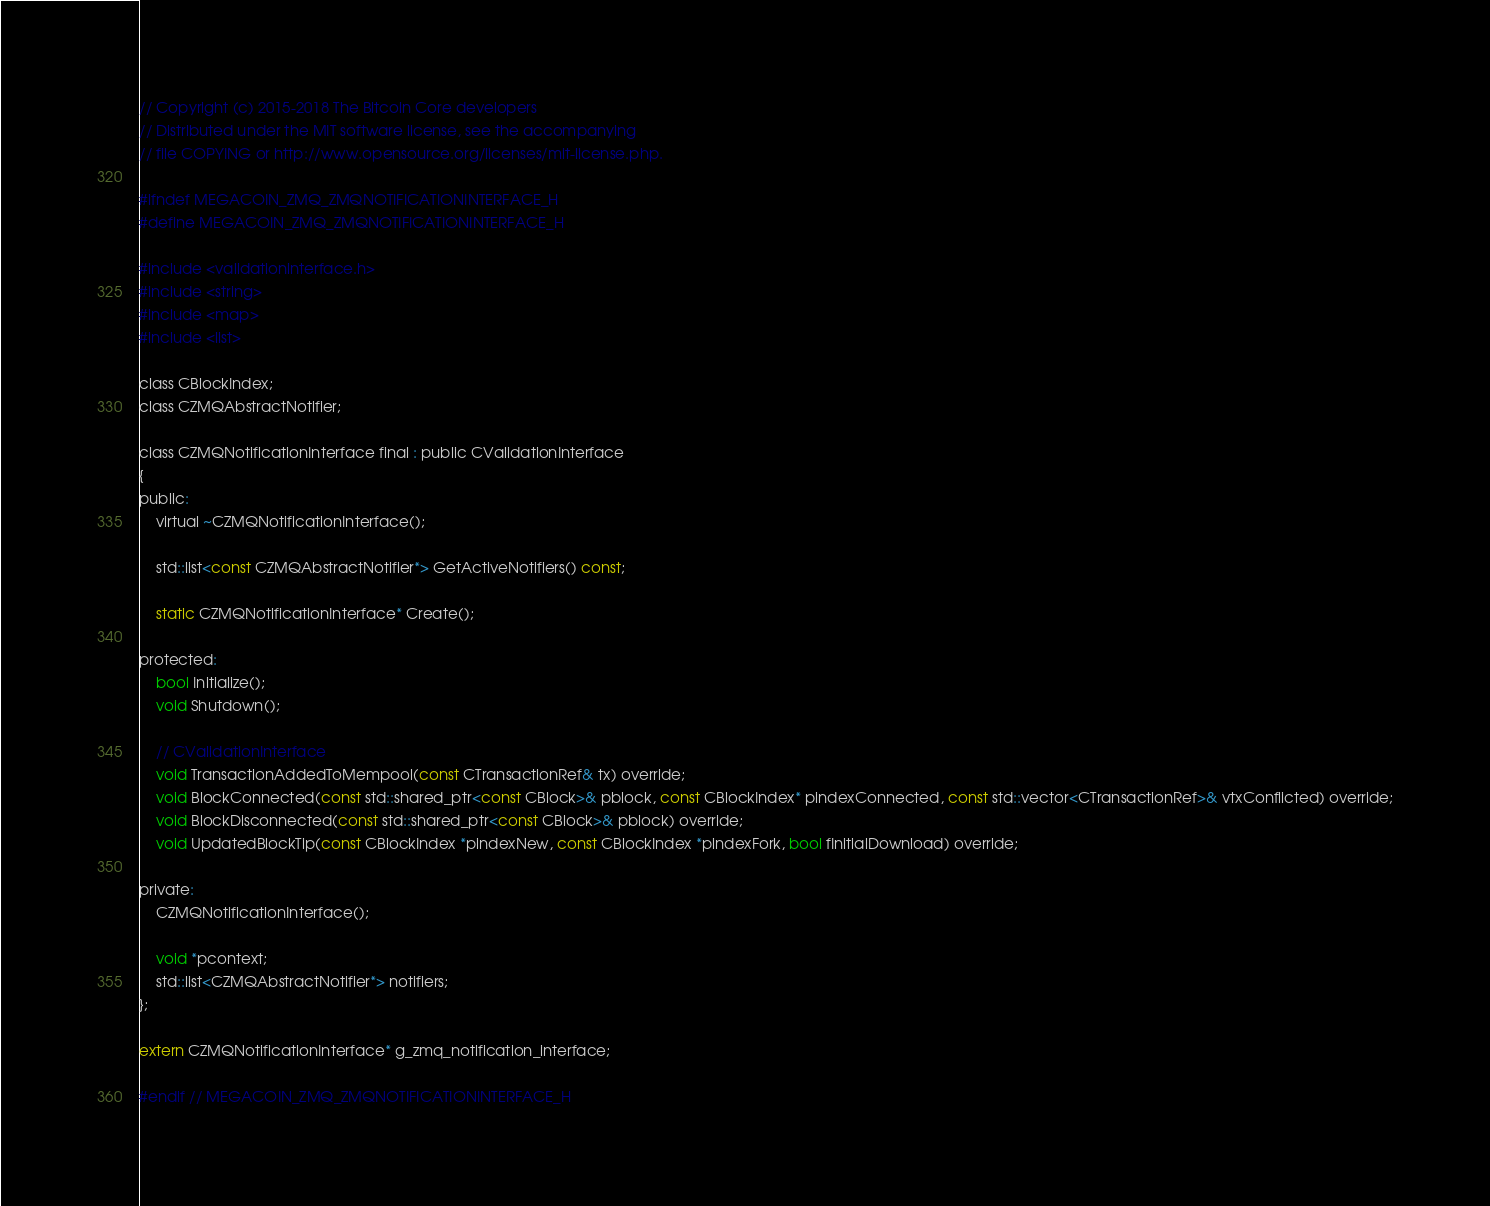Convert code to text. <code><loc_0><loc_0><loc_500><loc_500><_C_>// Copyright (c) 2015-2018 The Bitcoin Core developers
// Distributed under the MIT software license, see the accompanying
// file COPYING or http://www.opensource.org/licenses/mit-license.php.

#ifndef MEGACOIN_ZMQ_ZMQNOTIFICATIONINTERFACE_H
#define MEGACOIN_ZMQ_ZMQNOTIFICATIONINTERFACE_H

#include <validationinterface.h>
#include <string>
#include <map>
#include <list>

class CBlockIndex;
class CZMQAbstractNotifier;

class CZMQNotificationInterface final : public CValidationInterface
{
public:
    virtual ~CZMQNotificationInterface();

    std::list<const CZMQAbstractNotifier*> GetActiveNotifiers() const;

    static CZMQNotificationInterface* Create();

protected:
    bool Initialize();
    void Shutdown();

    // CValidationInterface
    void TransactionAddedToMempool(const CTransactionRef& tx) override;
    void BlockConnected(const std::shared_ptr<const CBlock>& pblock, const CBlockIndex* pindexConnected, const std::vector<CTransactionRef>& vtxConflicted) override;
    void BlockDisconnected(const std::shared_ptr<const CBlock>& pblock) override;
    void UpdatedBlockTip(const CBlockIndex *pindexNew, const CBlockIndex *pindexFork, bool fInitialDownload) override;

private:
    CZMQNotificationInterface();

    void *pcontext;
    std::list<CZMQAbstractNotifier*> notifiers;
};

extern CZMQNotificationInterface* g_zmq_notification_interface;

#endif // MEGACOIN_ZMQ_ZMQNOTIFICATIONINTERFACE_H
</code> 